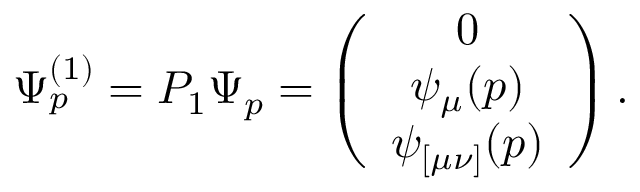<formula> <loc_0><loc_0><loc_500><loc_500>\Psi _ { p } ^ { ( 1 ) } = P _ { 1 } \Psi _ { p } = \left ( \begin{array} { c } { 0 } \\ { { \psi _ { \mu } ( p ) } } \\ { { \psi _ { [ \mu \nu ] } ( p ) } } \end{array} \right ) .</formula> 